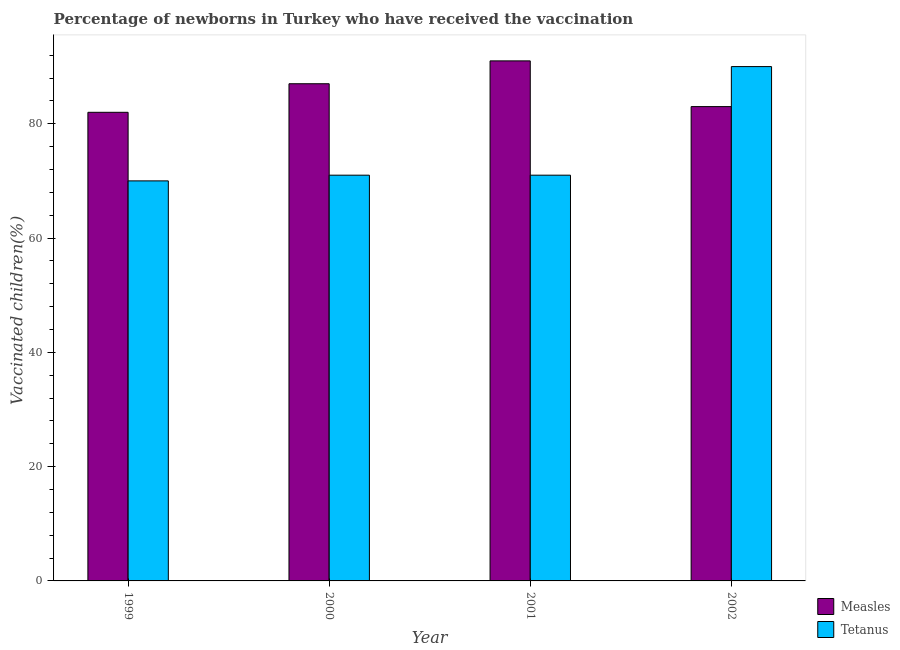Are the number of bars per tick equal to the number of legend labels?
Your answer should be very brief. Yes. How many bars are there on the 4th tick from the right?
Keep it short and to the point. 2. In how many cases, is the number of bars for a given year not equal to the number of legend labels?
Offer a very short reply. 0. What is the percentage of newborns who received vaccination for tetanus in 1999?
Your answer should be compact. 70. Across all years, what is the maximum percentage of newborns who received vaccination for measles?
Keep it short and to the point. 91. Across all years, what is the minimum percentage of newborns who received vaccination for tetanus?
Keep it short and to the point. 70. In which year was the percentage of newborns who received vaccination for tetanus maximum?
Give a very brief answer. 2002. What is the total percentage of newborns who received vaccination for tetanus in the graph?
Your answer should be compact. 302. What is the difference between the percentage of newborns who received vaccination for measles in 2001 and that in 2002?
Your answer should be very brief. 8. What is the difference between the percentage of newborns who received vaccination for measles in 2001 and the percentage of newborns who received vaccination for tetanus in 2002?
Offer a terse response. 8. What is the average percentage of newborns who received vaccination for tetanus per year?
Your answer should be compact. 75.5. In the year 2000, what is the difference between the percentage of newborns who received vaccination for tetanus and percentage of newborns who received vaccination for measles?
Provide a short and direct response. 0. In how many years, is the percentage of newborns who received vaccination for measles greater than 44 %?
Provide a short and direct response. 4. What is the ratio of the percentage of newborns who received vaccination for tetanus in 1999 to that in 2002?
Make the answer very short. 0.78. What is the difference between the highest and the second highest percentage of newborns who received vaccination for tetanus?
Give a very brief answer. 19. What is the difference between the highest and the lowest percentage of newborns who received vaccination for tetanus?
Keep it short and to the point. 20. What does the 2nd bar from the left in 2000 represents?
Your answer should be very brief. Tetanus. What does the 1st bar from the right in 2002 represents?
Provide a succinct answer. Tetanus. Does the graph contain any zero values?
Offer a terse response. No. Does the graph contain grids?
Provide a succinct answer. No. Where does the legend appear in the graph?
Provide a succinct answer. Bottom right. How are the legend labels stacked?
Your answer should be very brief. Vertical. What is the title of the graph?
Provide a short and direct response. Percentage of newborns in Turkey who have received the vaccination. What is the label or title of the X-axis?
Your response must be concise. Year. What is the label or title of the Y-axis?
Your answer should be compact. Vaccinated children(%)
. What is the Vaccinated children(%)
 in Tetanus in 2000?
Offer a terse response. 71. What is the Vaccinated children(%)
 of Measles in 2001?
Provide a succinct answer. 91. What is the Vaccinated children(%)
 of Tetanus in 2001?
Make the answer very short. 71. What is the Vaccinated children(%)
 of Measles in 2002?
Keep it short and to the point. 83. Across all years, what is the maximum Vaccinated children(%)
 in Measles?
Provide a succinct answer. 91. Across all years, what is the minimum Vaccinated children(%)
 in Measles?
Offer a terse response. 82. What is the total Vaccinated children(%)
 in Measles in the graph?
Make the answer very short. 343. What is the total Vaccinated children(%)
 in Tetanus in the graph?
Ensure brevity in your answer.  302. What is the difference between the Vaccinated children(%)
 in Tetanus in 1999 and that in 2000?
Offer a terse response. -1. What is the difference between the Vaccinated children(%)
 of Measles in 1999 and that in 2001?
Provide a succinct answer. -9. What is the difference between the Vaccinated children(%)
 in Tetanus in 1999 and that in 2001?
Keep it short and to the point. -1. What is the difference between the Vaccinated children(%)
 in Measles in 1999 and that in 2002?
Offer a very short reply. -1. What is the difference between the Vaccinated children(%)
 of Tetanus in 1999 and that in 2002?
Your response must be concise. -20. What is the difference between the Vaccinated children(%)
 in Measles in 2000 and that in 2001?
Provide a short and direct response. -4. What is the difference between the Vaccinated children(%)
 in Tetanus in 2000 and that in 2001?
Offer a terse response. 0. What is the difference between the Vaccinated children(%)
 in Measles in 2000 and that in 2002?
Offer a very short reply. 4. What is the difference between the Vaccinated children(%)
 of Measles in 2001 and that in 2002?
Give a very brief answer. 8. What is the difference between the Vaccinated children(%)
 of Measles in 1999 and the Vaccinated children(%)
 of Tetanus in 2000?
Offer a very short reply. 11. What is the difference between the Vaccinated children(%)
 of Measles in 1999 and the Vaccinated children(%)
 of Tetanus in 2001?
Offer a very short reply. 11. What is the difference between the Vaccinated children(%)
 in Measles in 1999 and the Vaccinated children(%)
 in Tetanus in 2002?
Give a very brief answer. -8. What is the difference between the Vaccinated children(%)
 of Measles in 2000 and the Vaccinated children(%)
 of Tetanus in 2001?
Keep it short and to the point. 16. What is the difference between the Vaccinated children(%)
 in Measles in 2000 and the Vaccinated children(%)
 in Tetanus in 2002?
Offer a very short reply. -3. What is the difference between the Vaccinated children(%)
 of Measles in 2001 and the Vaccinated children(%)
 of Tetanus in 2002?
Your response must be concise. 1. What is the average Vaccinated children(%)
 in Measles per year?
Provide a succinct answer. 85.75. What is the average Vaccinated children(%)
 in Tetanus per year?
Your answer should be compact. 75.5. In the year 2000, what is the difference between the Vaccinated children(%)
 of Measles and Vaccinated children(%)
 of Tetanus?
Offer a terse response. 16. In the year 2002, what is the difference between the Vaccinated children(%)
 of Measles and Vaccinated children(%)
 of Tetanus?
Provide a succinct answer. -7. What is the ratio of the Vaccinated children(%)
 of Measles in 1999 to that in 2000?
Provide a short and direct response. 0.94. What is the ratio of the Vaccinated children(%)
 of Tetanus in 1999 to that in 2000?
Make the answer very short. 0.99. What is the ratio of the Vaccinated children(%)
 in Measles in 1999 to that in 2001?
Give a very brief answer. 0.9. What is the ratio of the Vaccinated children(%)
 of Tetanus in 1999 to that in 2001?
Provide a short and direct response. 0.99. What is the ratio of the Vaccinated children(%)
 of Measles in 2000 to that in 2001?
Make the answer very short. 0.96. What is the ratio of the Vaccinated children(%)
 in Tetanus in 2000 to that in 2001?
Offer a terse response. 1. What is the ratio of the Vaccinated children(%)
 in Measles in 2000 to that in 2002?
Provide a short and direct response. 1.05. What is the ratio of the Vaccinated children(%)
 of Tetanus in 2000 to that in 2002?
Offer a very short reply. 0.79. What is the ratio of the Vaccinated children(%)
 in Measles in 2001 to that in 2002?
Give a very brief answer. 1.1. What is the ratio of the Vaccinated children(%)
 in Tetanus in 2001 to that in 2002?
Keep it short and to the point. 0.79. What is the difference between the highest and the second highest Vaccinated children(%)
 of Measles?
Provide a short and direct response. 4. 